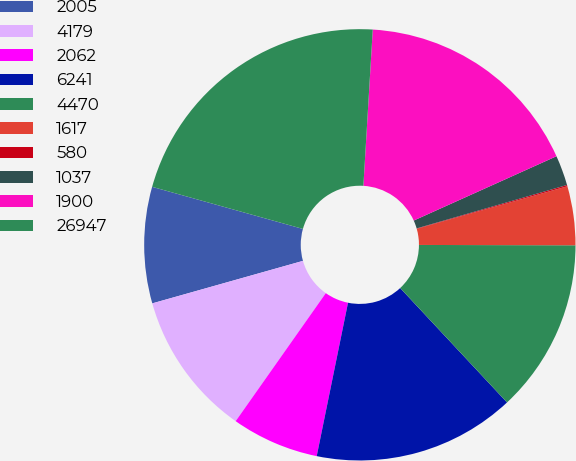Convert chart to OTSL. <chart><loc_0><loc_0><loc_500><loc_500><pie_chart><fcel>2005<fcel>4179<fcel>2062<fcel>6241<fcel>4470<fcel>1617<fcel>580<fcel>1037<fcel>1900<fcel>26947<nl><fcel>8.71%<fcel>10.86%<fcel>6.56%<fcel>15.16%<fcel>13.01%<fcel>4.41%<fcel>0.1%<fcel>2.26%<fcel>17.31%<fcel>21.62%<nl></chart> 